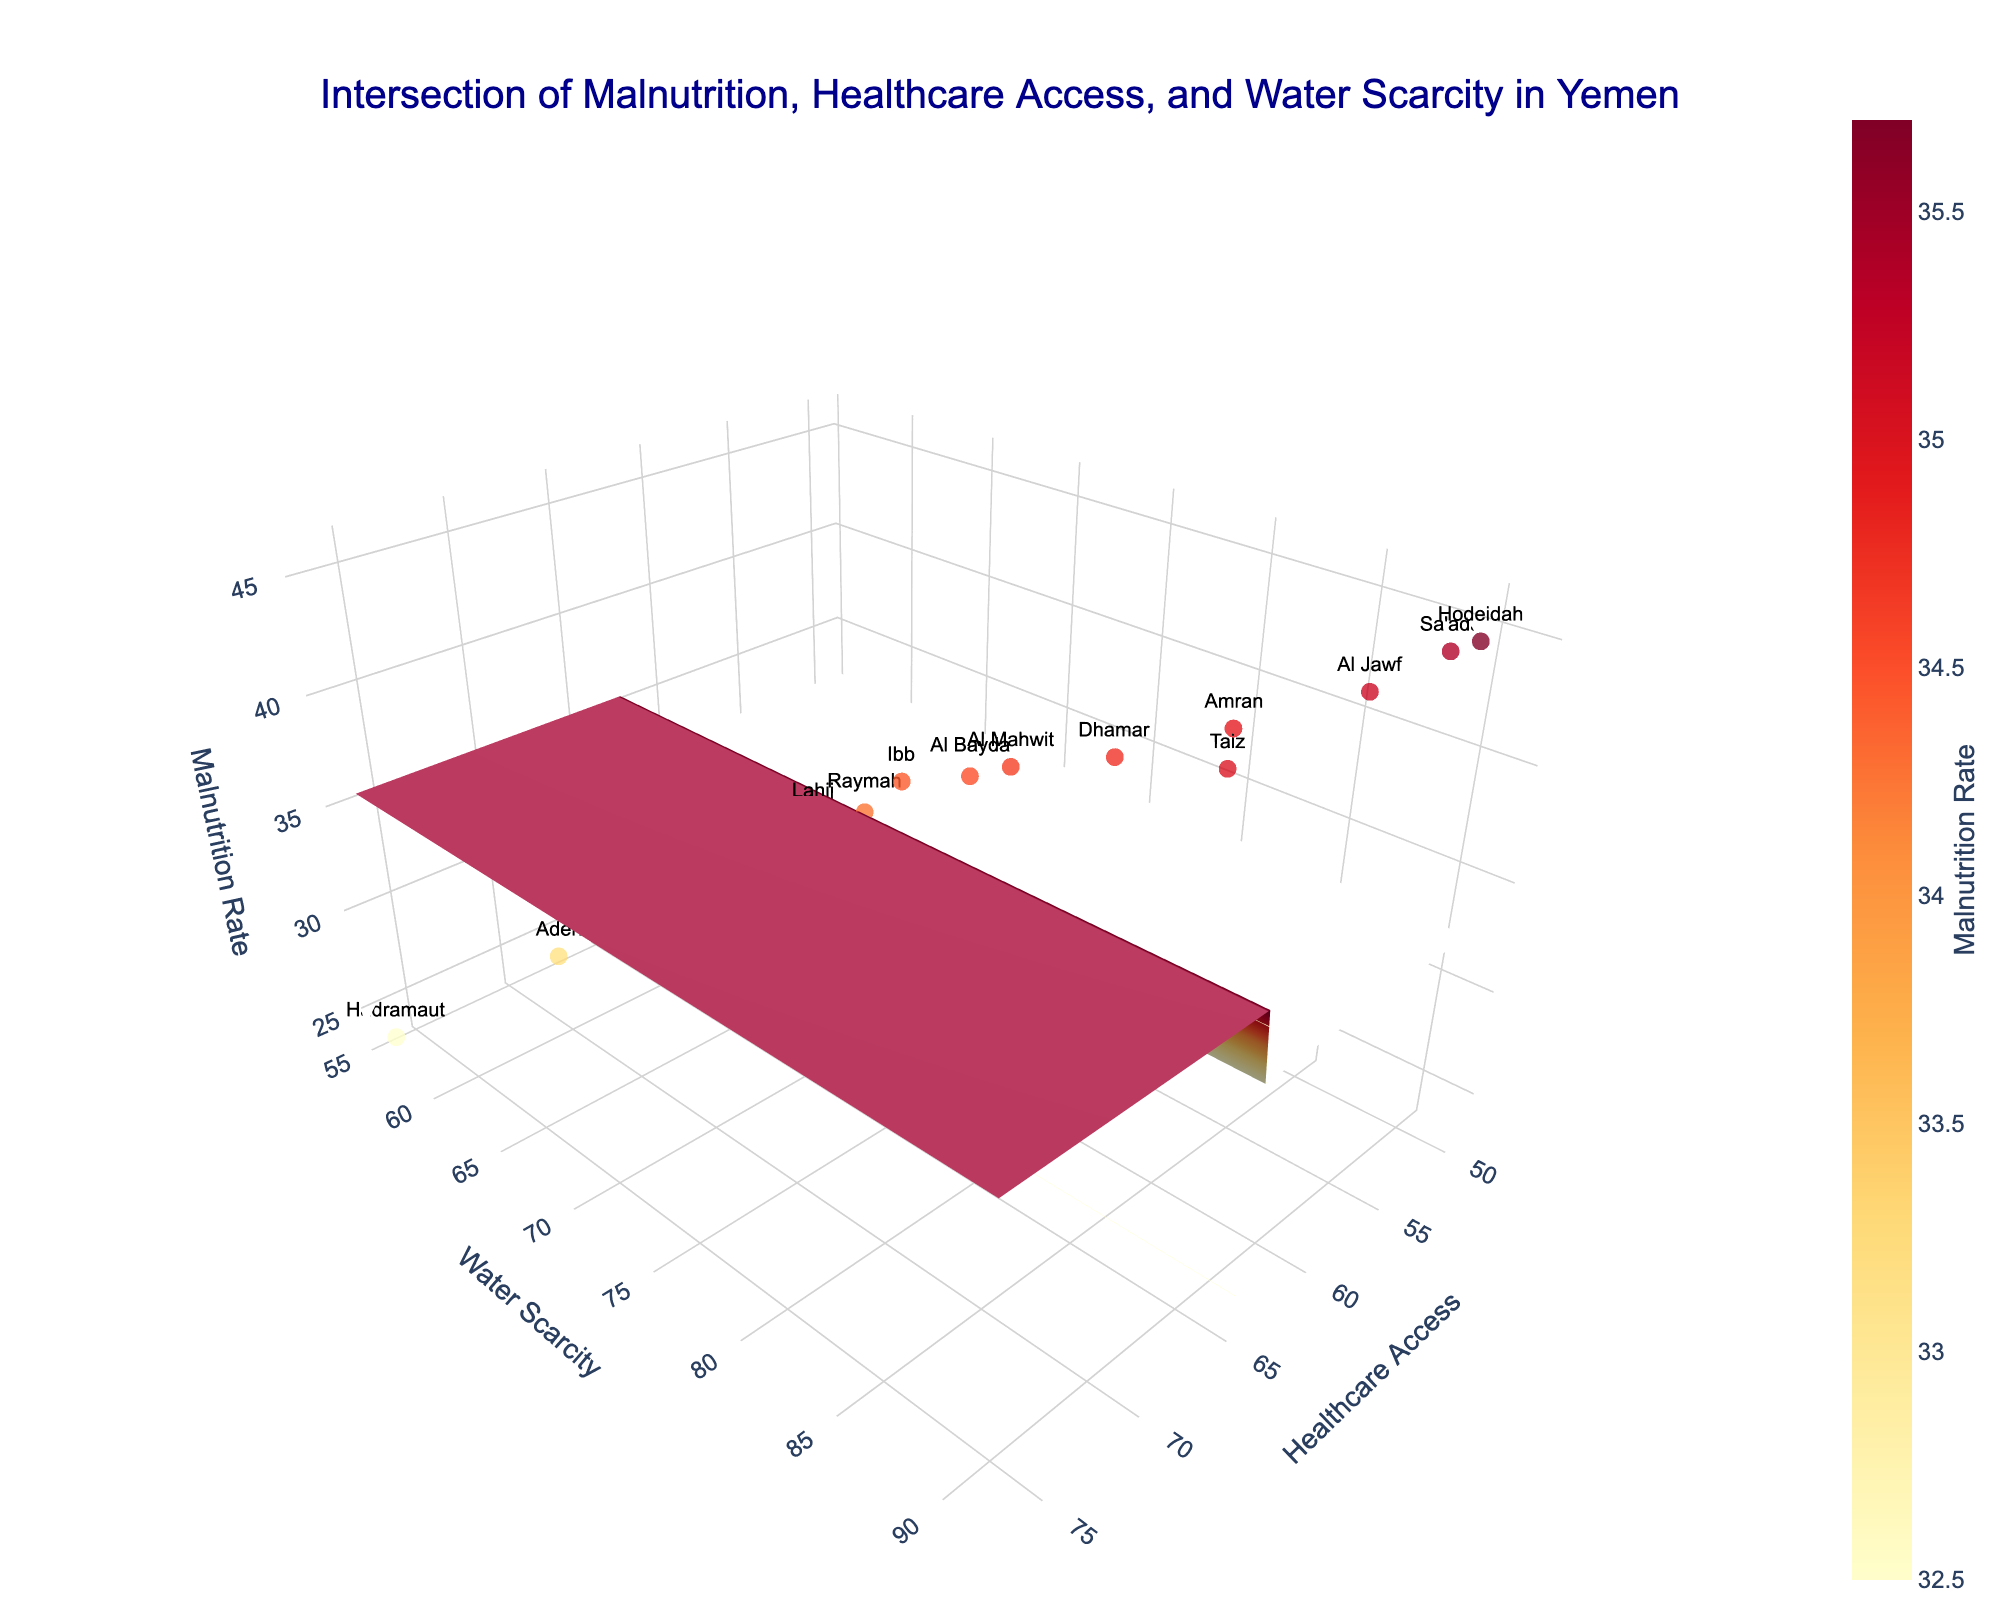What is the title of the 3D surface plot? The title of the plot is located at the top center of the figure. Look for the main heading text, which provides a summary of the visual data presented.
Answer: Intersection of Malnutrition, Healthcare Access, and Water Scarcity in Yemen What does the z-axis represent in the plot? The z-axis title is displayed on the vertical axis of the 3D plot. It indicates the variable represented by this axis.
Answer: Malnutrition Rate Which province has the highest malnutrition rate? To identify the province with the highest malnutrition rate, locate the data point with the highest z-value on the plot. Look for the label that corresponds to this point.
Answer: Hodeidah How does the water scarcity for Hodeidah compare to that for Aden? Examine the positions of the data points for Hodeidah and Aden along the y-axis, which represents water scarcity, and compare their heights.
Answer: Hodeidah has higher water scarcity than Aden What is the relationship between healthcare access and water scarcity for areas with high malnutrition rates? Trace the grid areas where malnutrition rates (z-values) are highest and observe the corresponding x (healthcare access) and y (water scarcity) coordinates. Generally, higher malnutrition occurs in regions with lower healthcare access and higher water scarcity.
Answer: High malnutrition rates are associated with low healthcare access and high water scarcity Which province has the best combination of high healthcare access and low water scarcity? Look for the data point with the highest x-value (healthcare access) combined with the lowest y-value (water scarcity). Then, check the corresponding province label.
Answer: Hadramaut What are the average values of malnutrition, healthcare access, and water scarcity across all provinces? To find the average values, sum up all individual values for each of the three variables across all provinces and divide by the number of provinces (15).
Answer: Average malnutrition: 35.9, Average healthcare access: 61.2, Average water scarcity: 75.0 In which provinces do malnutrition rates exceed 40%? Locate all data points with z-values (malnutrition rate) higher than 40%. Identify the corresponding province labels for these points.
Answer: Taiz, Hodeidah, Sa'ada, Amran, Al Jawf What patterns do you observe about regions with high water scarcity? Observe the distribution of data points along the y-axis (water scarcity). Identify any trends or notable patterns regarding malnutrition rates and healthcare access for these regions.
Answer: Regions with high water scarcity typically have high malnutrition rates and lower healthcare access How does the malnutrition rate trend change with increasing healthcare access? Follow the surface plot's gradient as you move along the x-axis (healthcare access). Describe the trend in the z-values (malnutrition rate).
Answer: As healthcare access increases, the malnutrition rate generally decreases 